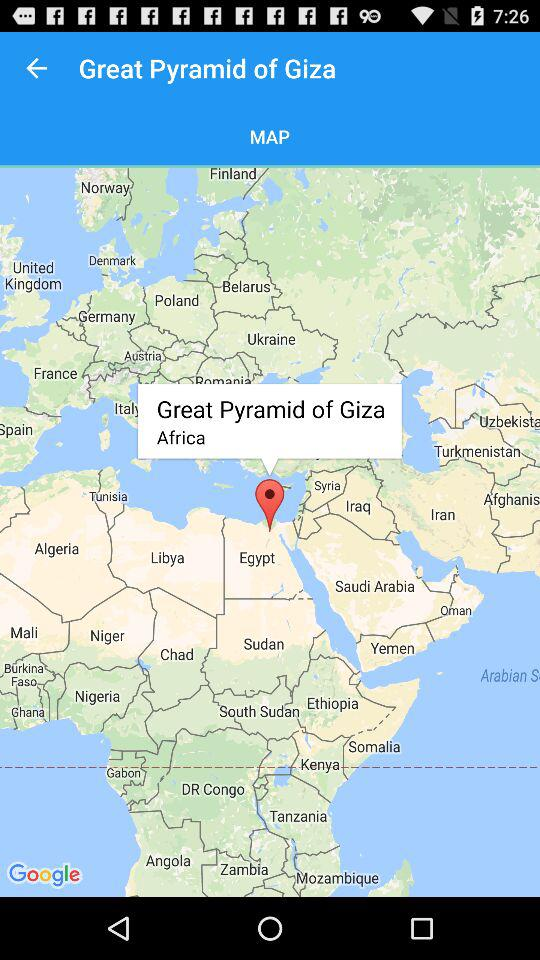What is the selected location? The selected location is the Great Pyramid of Giza, Africa. 